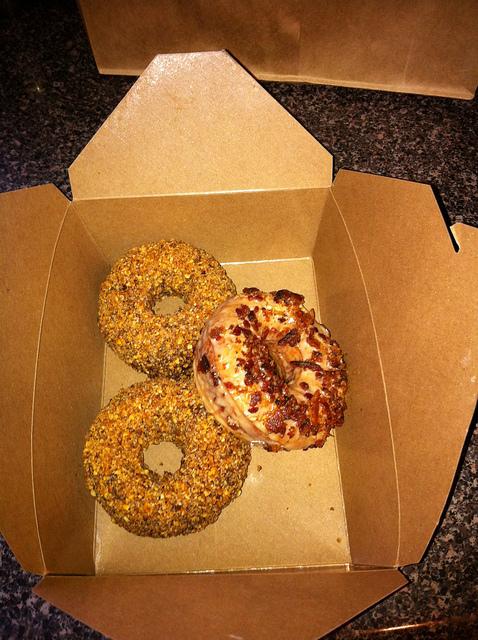Is anything else in the box?
Short answer required. Yes. How many doughnuts in the box?
Concise answer only. 3. Does this box have room for more doughnuts?
Short answer required. Yes. 